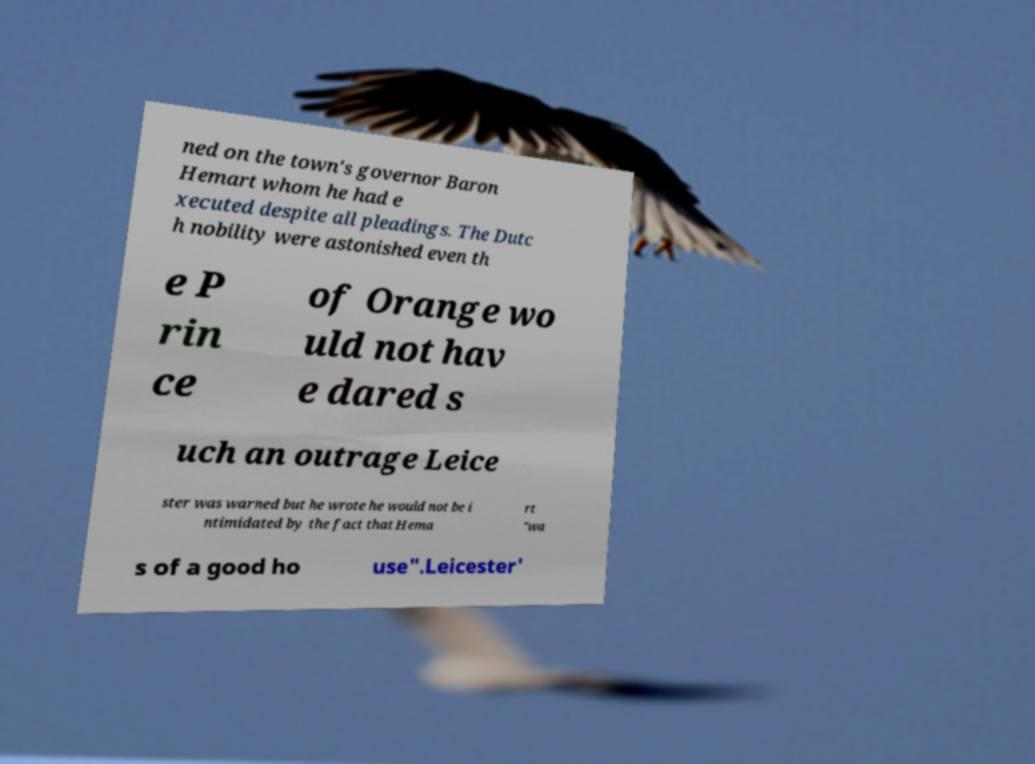I need the written content from this picture converted into text. Can you do that? ned on the town's governor Baron Hemart whom he had e xecuted despite all pleadings. The Dutc h nobility were astonished even th e P rin ce of Orange wo uld not hav e dared s uch an outrage Leice ster was warned but he wrote he would not be i ntimidated by the fact that Hema rt "wa s of a good ho use".Leicester' 